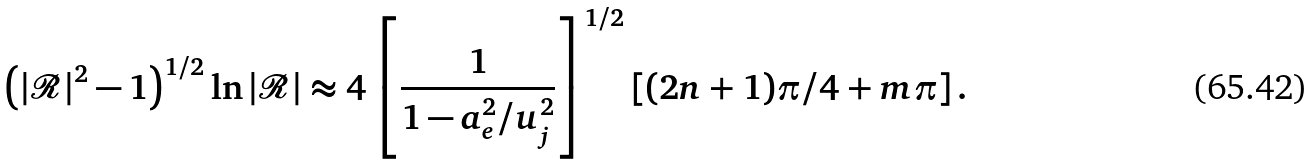<formula> <loc_0><loc_0><loc_500><loc_500>\left ( \left | \mathcal { R } \right | ^ { 2 } - 1 \right ) ^ { 1 / 2 } \ln \left | \mathcal { R } \right | \approx 4 \left [ \frac { 1 } { 1 - a _ { e } ^ { 2 } / u _ { j } ^ { 2 } } \right ] ^ { 1 / 2 } \left [ ( 2 n + 1 ) \pi / 4 + m \pi \right ] .</formula> 